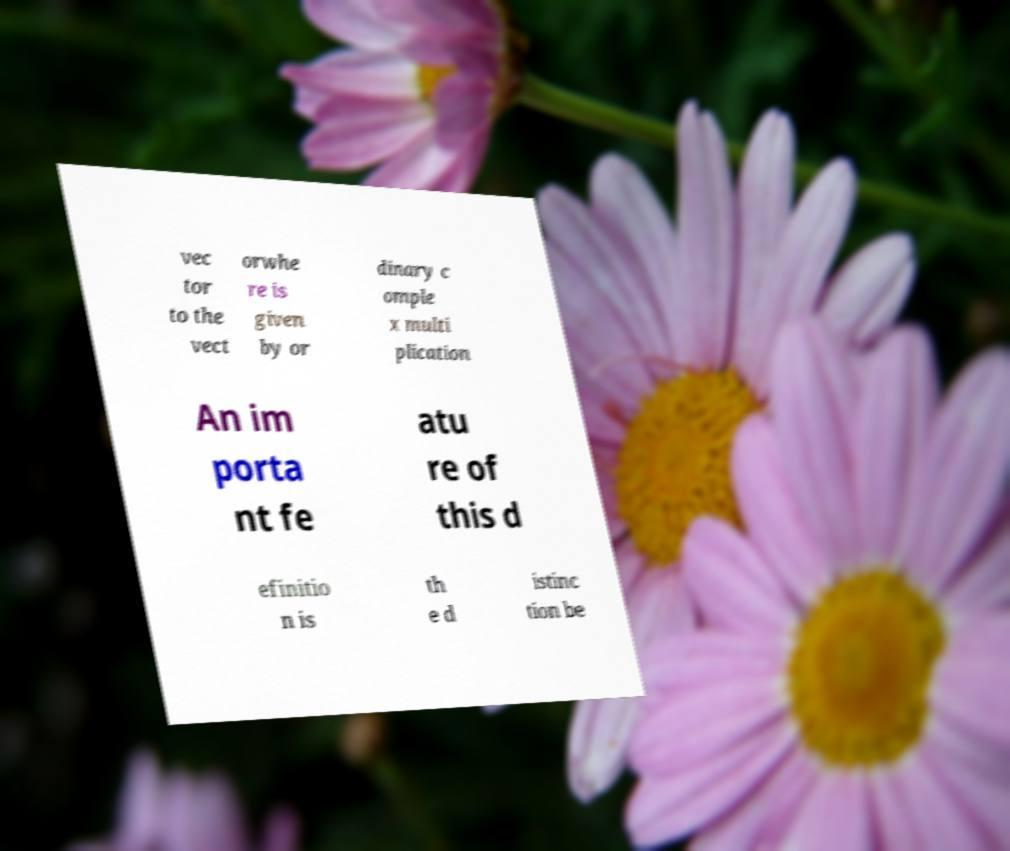Could you assist in decoding the text presented in this image and type it out clearly? vec tor to the vect orwhe re is given by or dinary c omple x multi plication An im porta nt fe atu re of this d efinitio n is th e d istinc tion be 